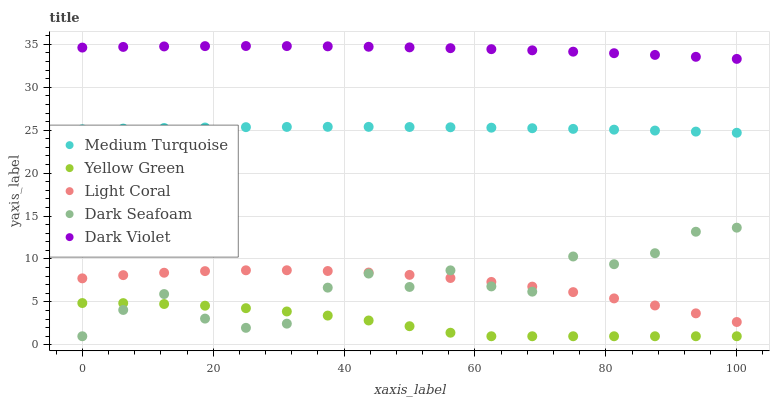Does Yellow Green have the minimum area under the curve?
Answer yes or no. Yes. Does Dark Violet have the maximum area under the curve?
Answer yes or no. Yes. Does Dark Seafoam have the minimum area under the curve?
Answer yes or no. No. Does Dark Seafoam have the maximum area under the curve?
Answer yes or no. No. Is Medium Turquoise the smoothest?
Answer yes or no. Yes. Is Dark Seafoam the roughest?
Answer yes or no. Yes. Is Dark Violet the smoothest?
Answer yes or no. No. Is Dark Violet the roughest?
Answer yes or no. No. Does Dark Seafoam have the lowest value?
Answer yes or no. Yes. Does Dark Violet have the lowest value?
Answer yes or no. No. Does Dark Violet have the highest value?
Answer yes or no. Yes. Does Dark Seafoam have the highest value?
Answer yes or no. No. Is Dark Seafoam less than Medium Turquoise?
Answer yes or no. Yes. Is Light Coral greater than Yellow Green?
Answer yes or no. Yes. Does Dark Seafoam intersect Yellow Green?
Answer yes or no. Yes. Is Dark Seafoam less than Yellow Green?
Answer yes or no. No. Is Dark Seafoam greater than Yellow Green?
Answer yes or no. No. Does Dark Seafoam intersect Medium Turquoise?
Answer yes or no. No. 